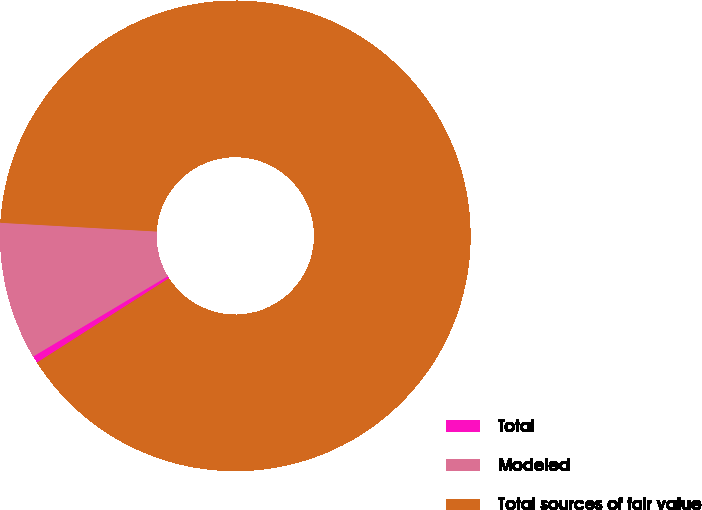Convert chart. <chart><loc_0><loc_0><loc_500><loc_500><pie_chart><fcel>Total<fcel>Modeled<fcel>Total sources of fair value<nl><fcel>0.49%<fcel>9.45%<fcel>90.05%<nl></chart> 